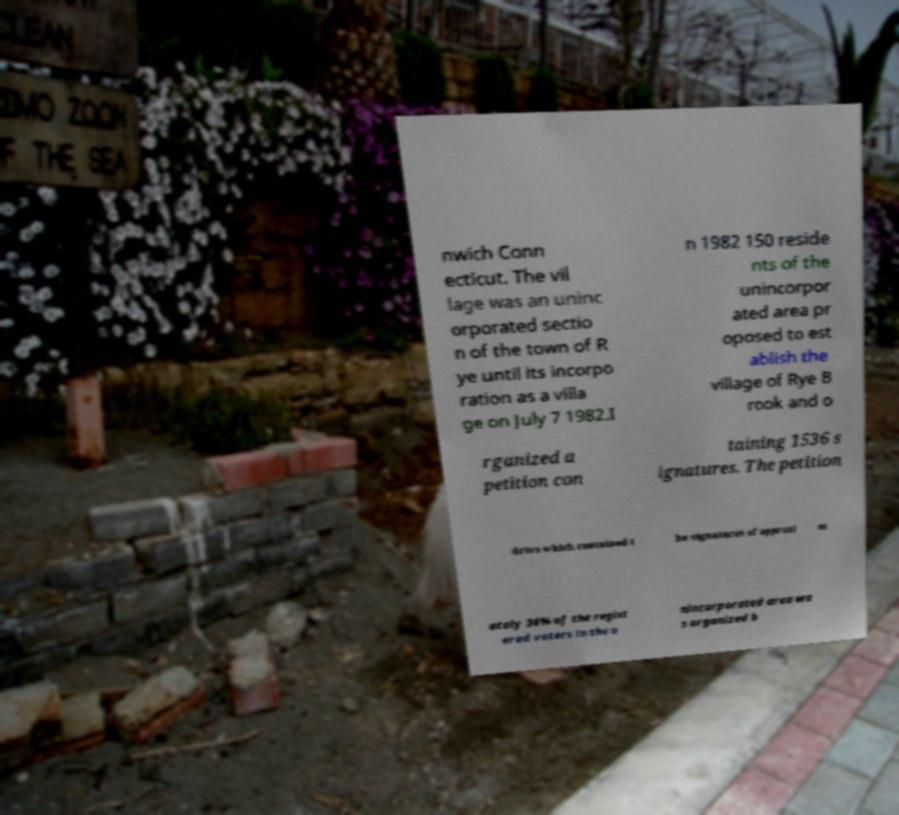Can you read and provide the text displayed in the image?This photo seems to have some interesting text. Can you extract and type it out for me? nwich Conn ecticut. The vil lage was an uninc orporated sectio n of the town of R ye until its incorpo ration as a villa ge on July 7 1982.I n 1982 150 reside nts of the unincorpor ated area pr oposed to est ablish the village of Rye B rook and o rganized a petition con taining 1536 s ignatures. The petition drive which contained t he signatures of approxi m ately 36% of the regist ered voters in the u nincorporated area wa s organized b 